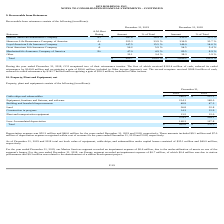According to Hc2 Holdings's financial document, What was the depreciation expense in 2019? According to the financial document, $52.3 million. The relevant text states: "Depreciation expense was $52.3 million and $46.6 million for the years ended December 31, 2019 and 2018, respectively. These amounts includ..." Also, What is the total property, plant and equipment in 2019? According to the financial document, $ 405.8 (in millions). The relevant text states: "Total $ 405.8 $ 376.3..." Also, What was the impairment expense for Energy segment in 2018? According to the financial document, $0.7 million. The relevant text states: "r Energy segment recorded an impairment expense of $0.7 million, of which $0.4 million was due to station performance and $0.3 million was related to the abandonme..." Also, can you calculate: What is the change in the Cable-ships and submersibles from 2018 to 2019? Based on the calculation: 246.5 - 251.1, the result is -4.6 (in millions). This is based on the information: "Cable-ships and submersibles $ 246.5 $ 251.1 Cable-ships and submersibles $ 246.5 $ 251.1..." The key data points involved are: 246.5, 251.1. Also, can you calculate: What is the average Equipment, furniture and fixtures, and software for 2018 and 2019? To answer this question, I need to perform calculations using the financial data. The calculation is: (214.1 + 148.0) / 2, which equals 181.05 (in millions). This is based on the information: "Equipment, furniture and fixtures, and software 214.1 148.0 pment, furniture and fixtures, and software 214.1 148.0..." The key data points involved are: 148.0, 214.1. Also, can you calculate: What is the average Building and leasehold improvements for 2018 and 2019? To answer this question, I need to perform calculations using the financial data. The calculation is: (48.9 + 47.3) / 2, which equals 48.1 (in millions). This is based on the information: "Building and leasehold improvements 48.9 47.3 Building and leasehold improvements 48.9 47.3..." The key data points involved are: 47.3, 48.9. 